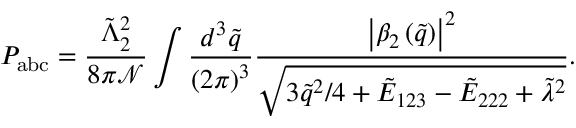Convert formula to latex. <formula><loc_0><loc_0><loc_500><loc_500>P _ { a b c } = \frac { \tilde { \Lambda } _ { 2 } ^ { 2 } } { 8 \pi \mathcal { N } } \int \frac { d ^ { 3 } \tilde { q } } { \left ( 2 \pi \right ) ^ { 3 } } \frac { \left | \beta _ { 2 } \left ( \tilde { q } \right ) \right | ^ { 2 } } { \sqrt { 3 \tilde { q } ^ { 2 } / 4 + \tilde { E } _ { 1 2 3 } - \tilde { E } _ { 2 2 2 } + \tilde { \lambda } ^ { 2 } } } .</formula> 